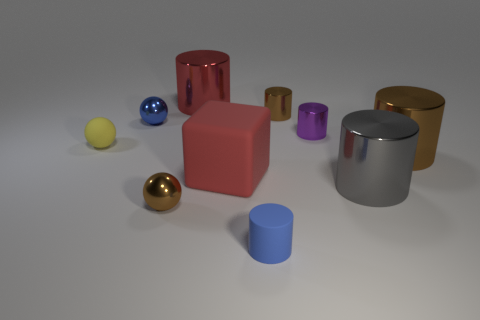How many things are either tiny brown metal cylinders or red rubber cylinders?
Provide a short and direct response. 1. The cylinder that is the same material as the block is what color?
Your answer should be very brief. Blue. Is the shape of the tiny brown thing on the left side of the tiny blue matte thing the same as  the purple metal object?
Your answer should be compact. No. What number of things are either brown objects that are behind the large brown thing or gray objects that are in front of the large brown metallic object?
Your answer should be compact. 2. The matte object that is the same shape as the small purple metallic object is what color?
Keep it short and to the point. Blue. Is there anything else that is the same shape as the yellow rubber object?
Provide a succinct answer. Yes. Do the large rubber thing and the tiny rubber thing that is behind the gray thing have the same shape?
Your response must be concise. No. What is the large block made of?
Your answer should be very brief. Rubber. What size is the yellow rubber object that is the same shape as the blue metallic thing?
Provide a succinct answer. Small. What number of other objects are the same material as the big red cylinder?
Provide a succinct answer. 6. 